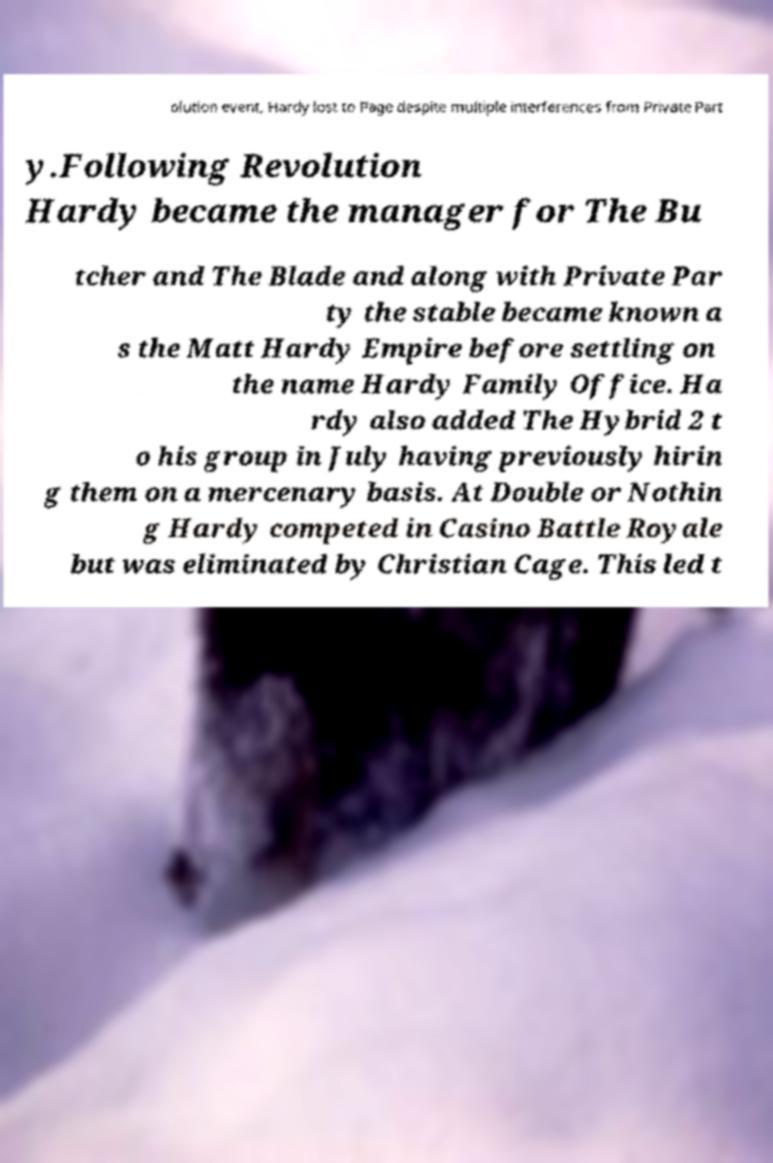There's text embedded in this image that I need extracted. Can you transcribe it verbatim? olution event, Hardy lost to Page despite multiple interferences from Private Part y.Following Revolution Hardy became the manager for The Bu tcher and The Blade and along with Private Par ty the stable became known a s the Matt Hardy Empire before settling on the name Hardy Family Office. Ha rdy also added The Hybrid 2 t o his group in July having previously hirin g them on a mercenary basis. At Double or Nothin g Hardy competed in Casino Battle Royale but was eliminated by Christian Cage. This led t 